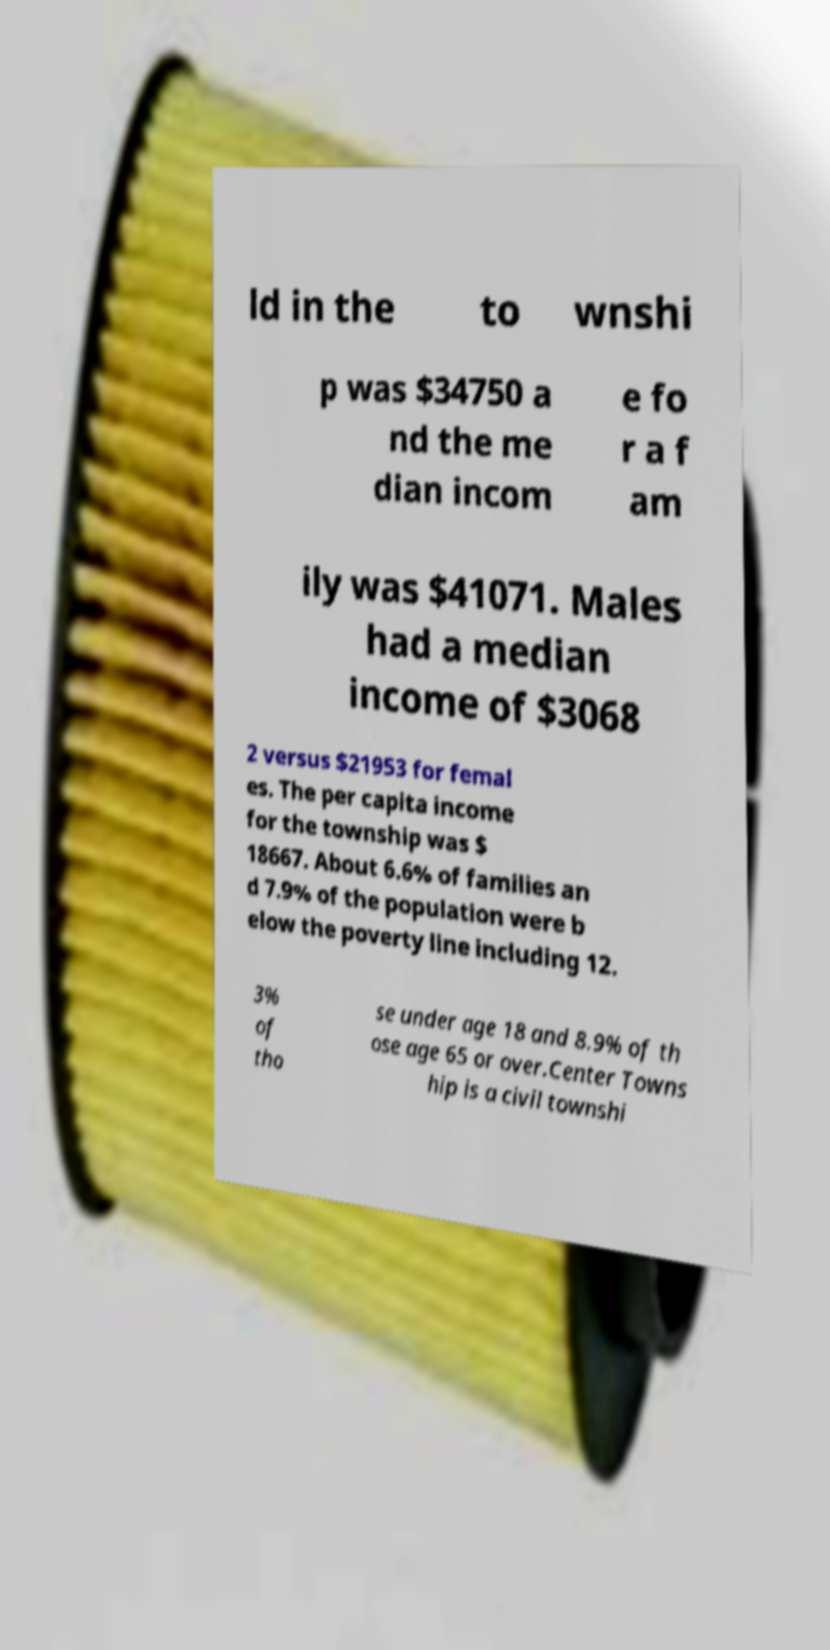Please identify and transcribe the text found in this image. ld in the to wnshi p was $34750 a nd the me dian incom e fo r a f am ily was $41071. Males had a median income of $3068 2 versus $21953 for femal es. The per capita income for the township was $ 18667. About 6.6% of families an d 7.9% of the population were b elow the poverty line including 12. 3% of tho se under age 18 and 8.9% of th ose age 65 or over.Center Towns hip is a civil townshi 